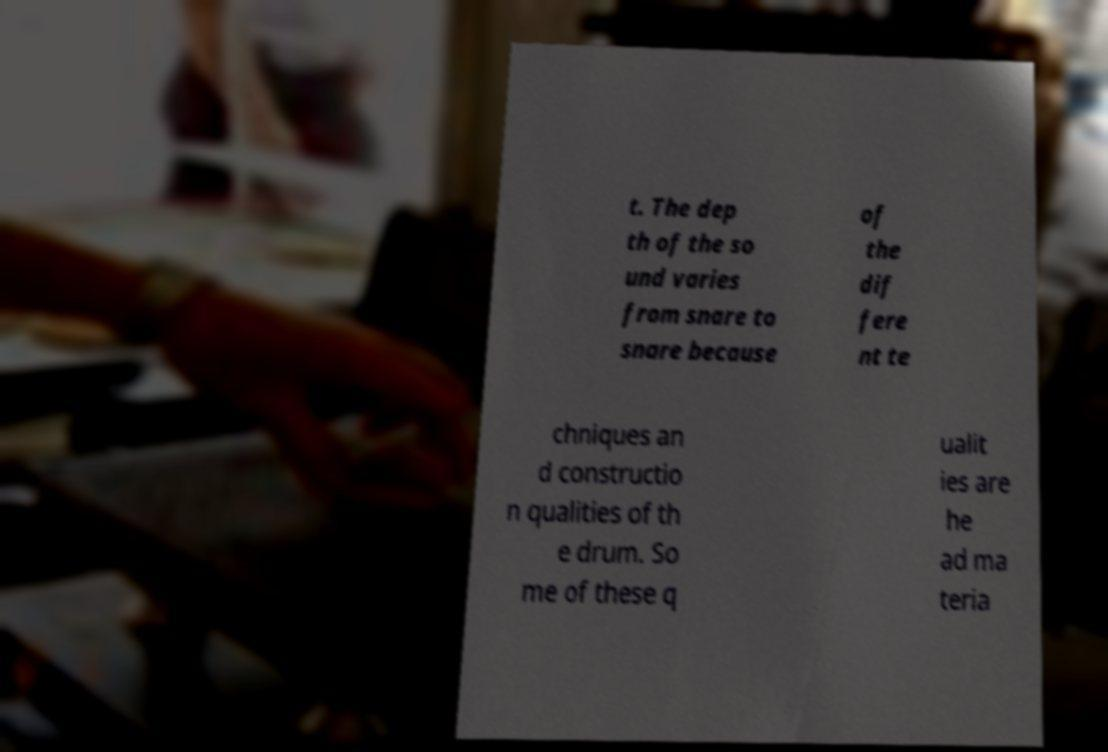There's text embedded in this image that I need extracted. Can you transcribe it verbatim? t. The dep th of the so und varies from snare to snare because of the dif fere nt te chniques an d constructio n qualities of th e drum. So me of these q ualit ies are he ad ma teria 